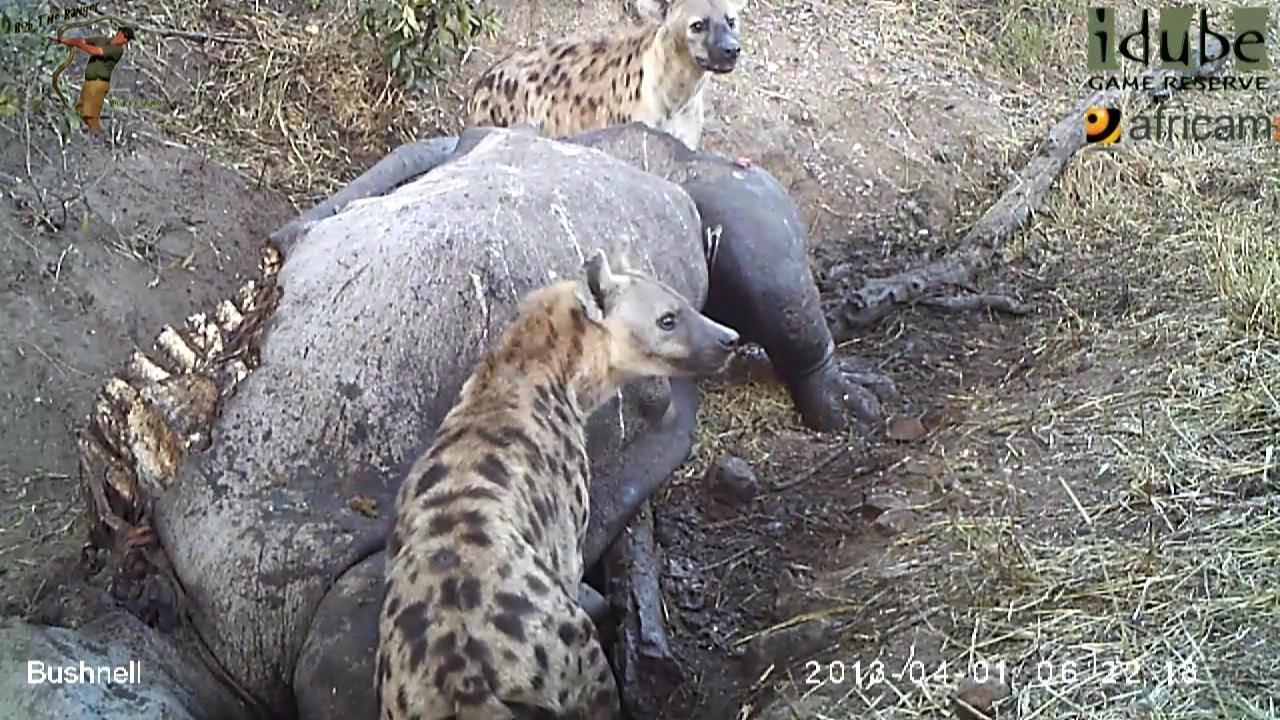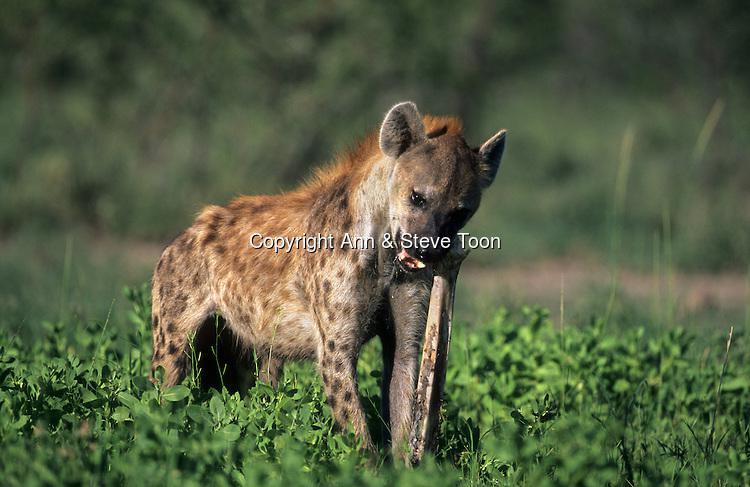The first image is the image on the left, the second image is the image on the right. Assess this claim about the two images: "The right image contains exactly one hyena.". Correct or not? Answer yes or no. Yes. The first image is the image on the left, the second image is the image on the right. For the images displayed, is the sentence "There is at least one hyena in the left image." factually correct? Answer yes or no. Yes. 